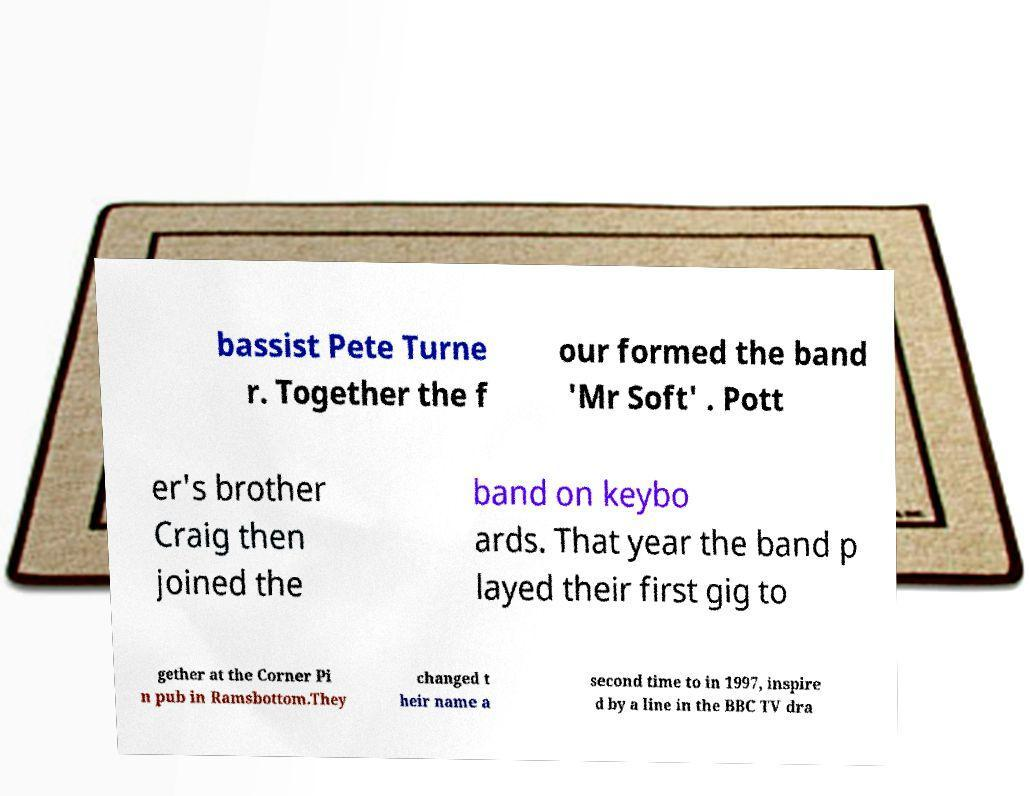Could you assist in decoding the text presented in this image and type it out clearly? bassist Pete Turne r. Together the f our formed the band 'Mr Soft' . Pott er's brother Craig then joined the band on keybo ards. That year the band p layed their first gig to gether at the Corner Pi n pub in Ramsbottom.They changed t heir name a second time to in 1997, inspire d by a line in the BBC TV dra 